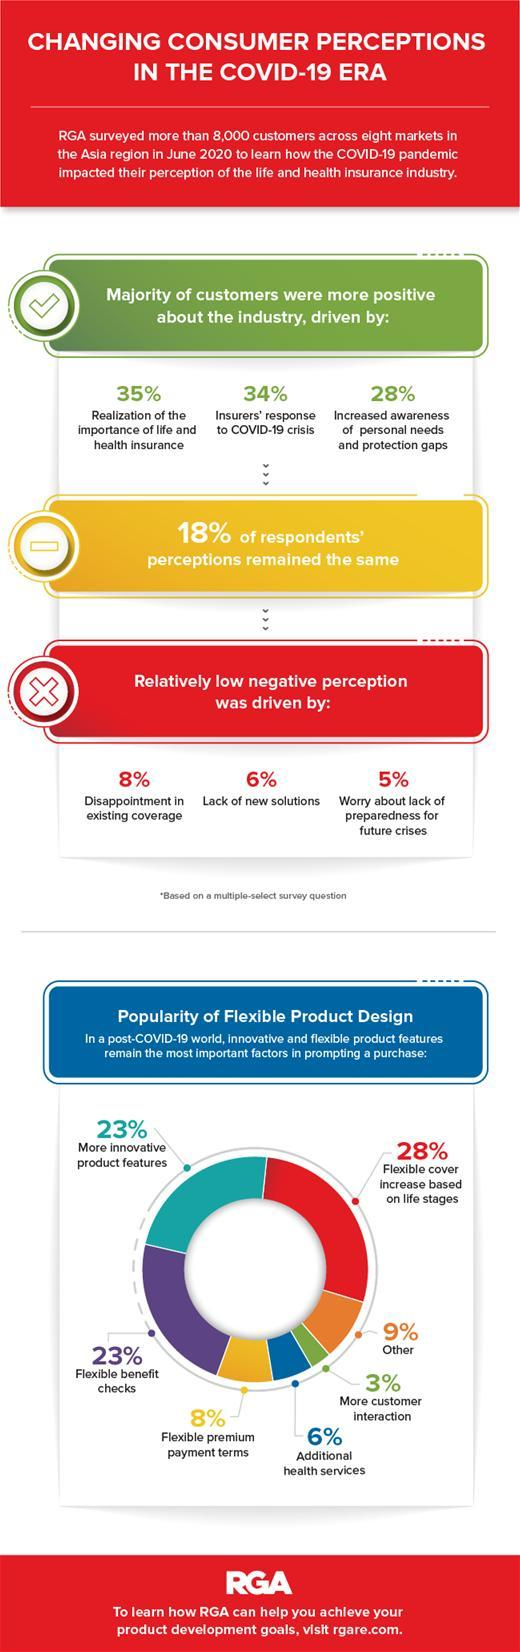Which is the most important factor in product design according to the pie chart?
Answer the question with a short phrase. flexible cover increase based on life stages What is the percentage of flexible and innovative factors in product design taking together? 51% total count of the word "COVID-19" is? 4 Which factor lead more to have positive perception about the industry? realization of the important of life and health insurance which are the two factors that are equally important in product design? more innovative product features, flexible benefit checks Which factor lead more to have negative perception about the industry? disappointment in existing coverage Which is the least important factor in product design according to the pie chart? more customer interaction What percent of people changed their perception? 82 What is the percentage of flexible premium payment terms and additional health services taking together? 14 What is the percentage of flexible benefit checks and premium payment terms taking together? 31% 